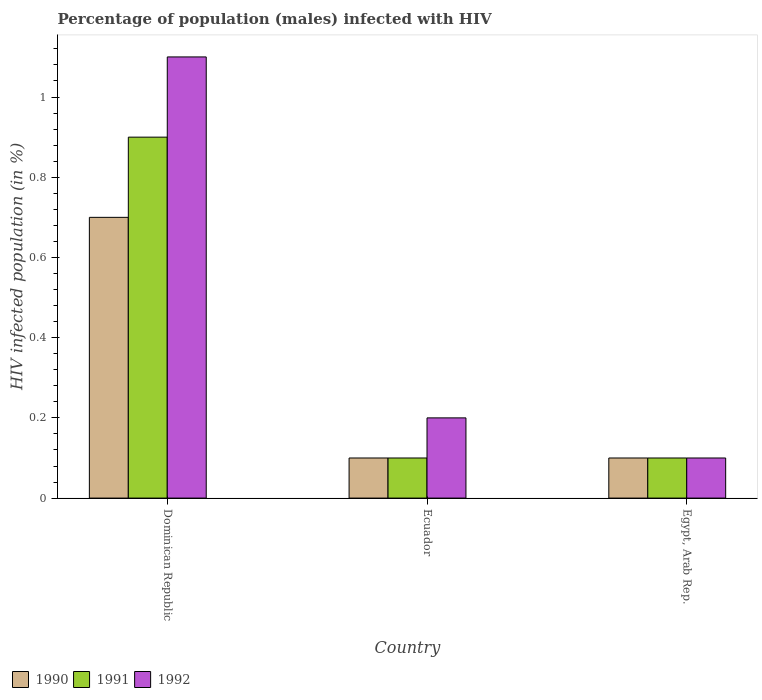How many groups of bars are there?
Give a very brief answer. 3. Are the number of bars per tick equal to the number of legend labels?
Offer a terse response. Yes. How many bars are there on the 3rd tick from the left?
Keep it short and to the point. 3. What is the label of the 3rd group of bars from the left?
Your answer should be compact. Egypt, Arab Rep. Across all countries, what is the maximum percentage of HIV infected male population in 1992?
Offer a very short reply. 1.1. In which country was the percentage of HIV infected male population in 1991 maximum?
Offer a terse response. Dominican Republic. In which country was the percentage of HIV infected male population in 1990 minimum?
Ensure brevity in your answer.  Ecuador. What is the total percentage of HIV infected male population in 1992 in the graph?
Your response must be concise. 1.4. What is the difference between the percentage of HIV infected male population in 1991 in Dominican Republic and that in Egypt, Arab Rep.?
Offer a terse response. 0.8. What is the difference between the percentage of HIV infected male population of/in 1992 and percentage of HIV infected male population of/in 1990 in Ecuador?
Ensure brevity in your answer.  0.1. In how many countries, is the percentage of HIV infected male population in 1990 greater than 0.7200000000000001 %?
Offer a terse response. 0. What is the ratio of the percentage of HIV infected male population in 1991 in Dominican Republic to that in Egypt, Arab Rep.?
Keep it short and to the point. 9. What is the difference between the highest and the lowest percentage of HIV infected male population in 1992?
Make the answer very short. 1. What does the 2nd bar from the left in Dominican Republic represents?
Keep it short and to the point. 1991. What does the 2nd bar from the right in Dominican Republic represents?
Provide a short and direct response. 1991. How many bars are there?
Ensure brevity in your answer.  9. Are all the bars in the graph horizontal?
Give a very brief answer. No. What is the difference between two consecutive major ticks on the Y-axis?
Make the answer very short. 0.2. Are the values on the major ticks of Y-axis written in scientific E-notation?
Your answer should be very brief. No. Does the graph contain grids?
Offer a terse response. No. Where does the legend appear in the graph?
Provide a short and direct response. Bottom left. How many legend labels are there?
Your answer should be very brief. 3. What is the title of the graph?
Provide a short and direct response. Percentage of population (males) infected with HIV. Does "1971" appear as one of the legend labels in the graph?
Your answer should be compact. No. What is the label or title of the X-axis?
Your answer should be very brief. Country. What is the label or title of the Y-axis?
Your answer should be compact. HIV infected population (in %). What is the HIV infected population (in %) in 1990 in Dominican Republic?
Make the answer very short. 0.7. What is the HIV infected population (in %) in 1992 in Dominican Republic?
Your response must be concise. 1.1. What is the HIV infected population (in %) in 1990 in Ecuador?
Your answer should be compact. 0.1. What is the HIV infected population (in %) of 1992 in Ecuador?
Ensure brevity in your answer.  0.2. What is the HIV infected population (in %) of 1990 in Egypt, Arab Rep.?
Your answer should be compact. 0.1. What is the HIV infected population (in %) of 1991 in Egypt, Arab Rep.?
Offer a very short reply. 0.1. What is the HIV infected population (in %) in 1992 in Egypt, Arab Rep.?
Offer a very short reply. 0.1. Across all countries, what is the minimum HIV infected population (in %) in 1990?
Your response must be concise. 0.1. Across all countries, what is the minimum HIV infected population (in %) in 1992?
Your answer should be compact. 0.1. What is the difference between the HIV infected population (in %) of 1990 in Dominican Republic and that in Ecuador?
Your answer should be compact. 0.6. What is the difference between the HIV infected population (in %) of 1991 in Ecuador and that in Egypt, Arab Rep.?
Keep it short and to the point. 0. What is the difference between the HIV infected population (in %) in 1992 in Ecuador and that in Egypt, Arab Rep.?
Offer a very short reply. 0.1. What is the difference between the HIV infected population (in %) in 1990 in Dominican Republic and the HIV infected population (in %) in 1991 in Ecuador?
Provide a short and direct response. 0.6. What is the difference between the HIV infected population (in %) in 1990 in Dominican Republic and the HIV infected population (in %) in 1992 in Ecuador?
Your answer should be very brief. 0.5. What is the difference between the HIV infected population (in %) of 1991 in Dominican Republic and the HIV infected population (in %) of 1992 in Ecuador?
Your response must be concise. 0.7. What is the difference between the HIV infected population (in %) of 1990 in Dominican Republic and the HIV infected population (in %) of 1991 in Egypt, Arab Rep.?
Keep it short and to the point. 0.6. What is the difference between the HIV infected population (in %) of 1990 in Dominican Republic and the HIV infected population (in %) of 1992 in Egypt, Arab Rep.?
Give a very brief answer. 0.6. What is the difference between the HIV infected population (in %) of 1990 in Ecuador and the HIV infected population (in %) of 1992 in Egypt, Arab Rep.?
Your answer should be very brief. 0. What is the difference between the HIV infected population (in %) in 1991 in Ecuador and the HIV infected population (in %) in 1992 in Egypt, Arab Rep.?
Ensure brevity in your answer.  0. What is the average HIV infected population (in %) in 1991 per country?
Your response must be concise. 0.37. What is the average HIV infected population (in %) in 1992 per country?
Your answer should be compact. 0.47. What is the difference between the HIV infected population (in %) in 1990 and HIV infected population (in %) in 1991 in Dominican Republic?
Ensure brevity in your answer.  -0.2. What is the difference between the HIV infected population (in %) in 1990 and HIV infected population (in %) in 1992 in Dominican Republic?
Offer a terse response. -0.4. What is the difference between the HIV infected population (in %) in 1990 and HIV infected population (in %) in 1991 in Egypt, Arab Rep.?
Your answer should be very brief. 0. What is the difference between the HIV infected population (in %) of 1990 and HIV infected population (in %) of 1992 in Egypt, Arab Rep.?
Make the answer very short. 0. What is the difference between the HIV infected population (in %) in 1991 and HIV infected population (in %) in 1992 in Egypt, Arab Rep.?
Offer a terse response. 0. What is the ratio of the HIV infected population (in %) in 1991 in Dominican Republic to that in Ecuador?
Give a very brief answer. 9. What is the ratio of the HIV infected population (in %) of 1990 in Dominican Republic to that in Egypt, Arab Rep.?
Your answer should be compact. 7. What is the ratio of the HIV infected population (in %) in 1991 in Dominican Republic to that in Egypt, Arab Rep.?
Make the answer very short. 9. What is the ratio of the HIV infected population (in %) of 1992 in Ecuador to that in Egypt, Arab Rep.?
Provide a succinct answer. 2. 